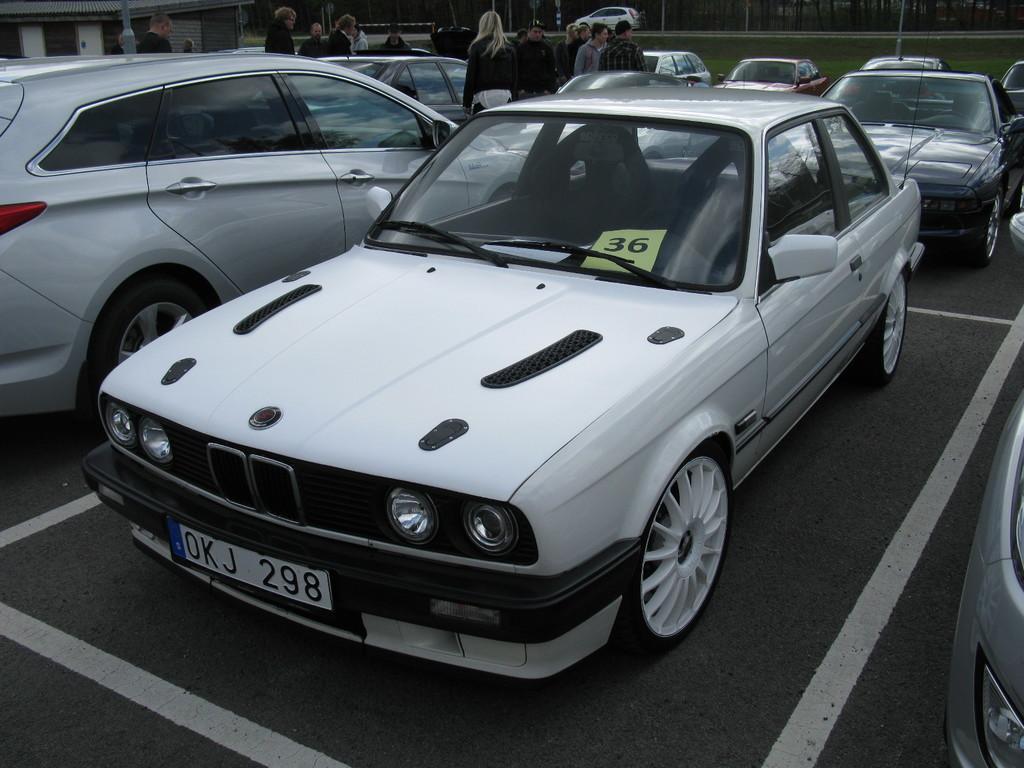Describe this image in one or two sentences. In this image we can see a few vehicles and people, also we can see a building and in the background we can see some poles. 